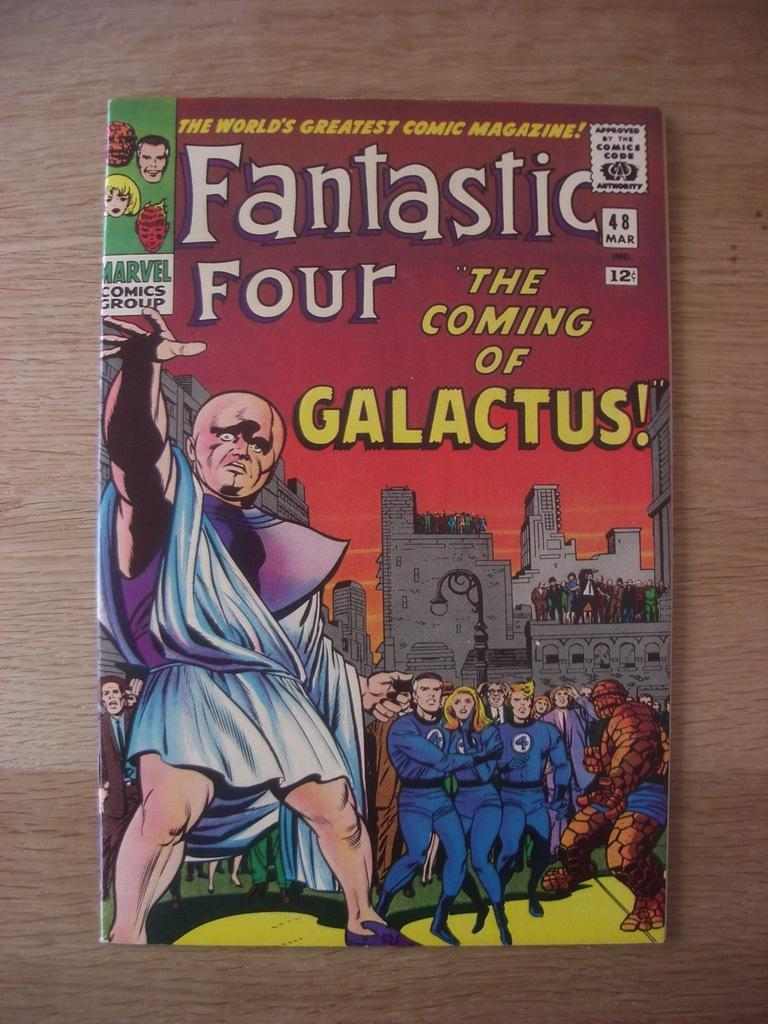<image>
Summarize the visual content of the image. A Fantastic Four comic book called The Coming of Galactus. 